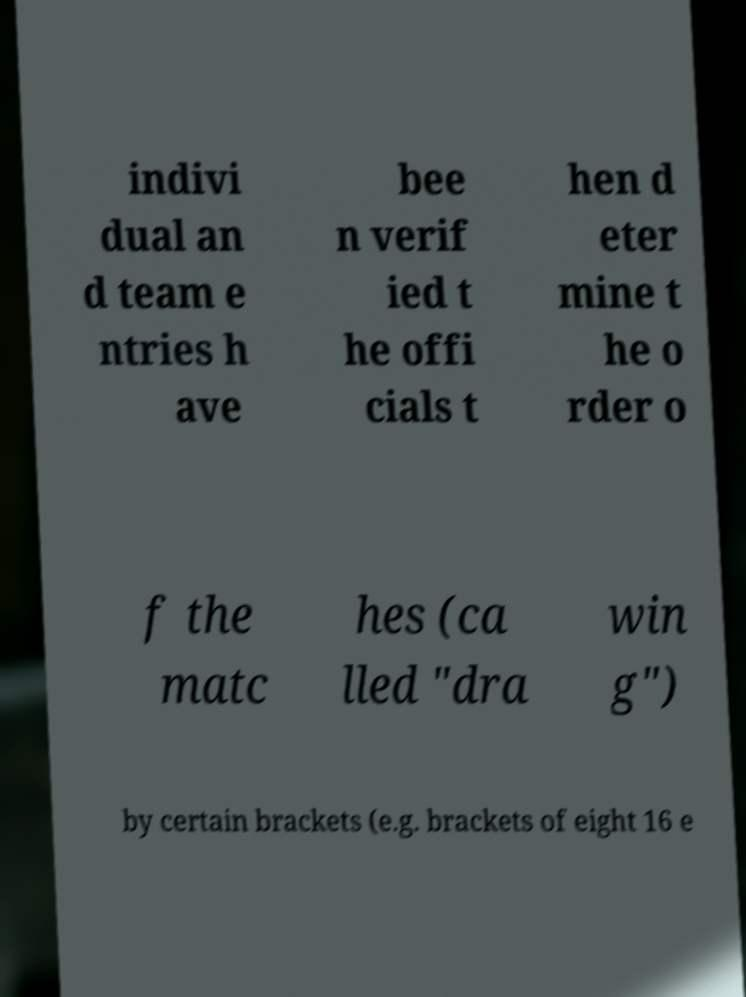Could you extract and type out the text from this image? indivi dual an d team e ntries h ave bee n verif ied t he offi cials t hen d eter mine t he o rder o f the matc hes (ca lled "dra win g") by certain brackets (e.g. brackets of eight 16 e 